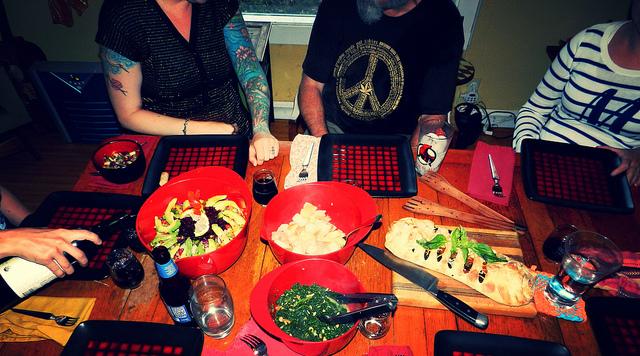Where is the letter M?
Give a very brief answer. Shirt. How many cups on the table?
Give a very brief answer. 5. What is the table made of?
Keep it brief. Wood. 